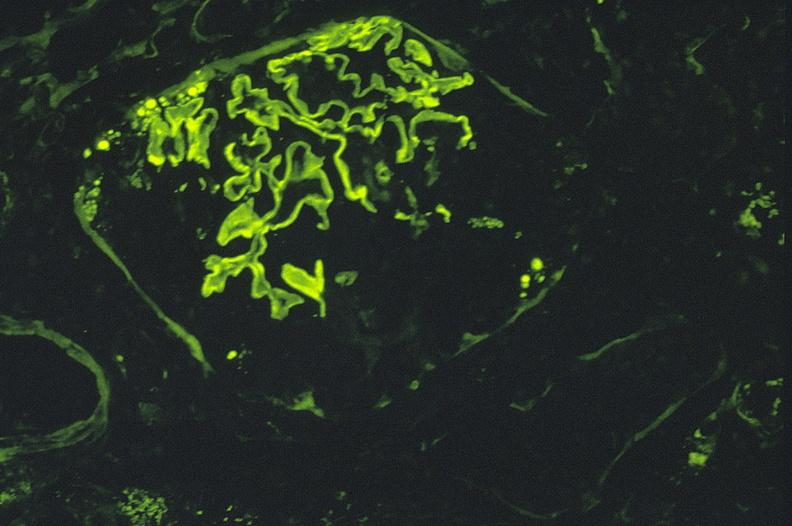what is present?
Answer the question using a single word or phrase. Urinary 